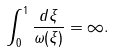<formula> <loc_0><loc_0><loc_500><loc_500>\int _ { 0 } ^ { 1 } \frac { d \xi } { \omega ( \xi ) } = \infty .</formula> 